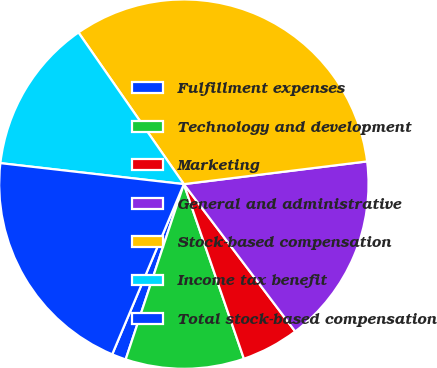Convert chart to OTSL. <chart><loc_0><loc_0><loc_500><loc_500><pie_chart><fcel>Fulfillment expenses<fcel>Technology and development<fcel>Marketing<fcel>General and administrative<fcel>Stock-based compensation<fcel>Income tax benefit<fcel>Total stock-based compensation<nl><fcel>1.24%<fcel>10.37%<fcel>5.03%<fcel>16.66%<fcel>32.7%<fcel>13.52%<fcel>20.47%<nl></chart> 